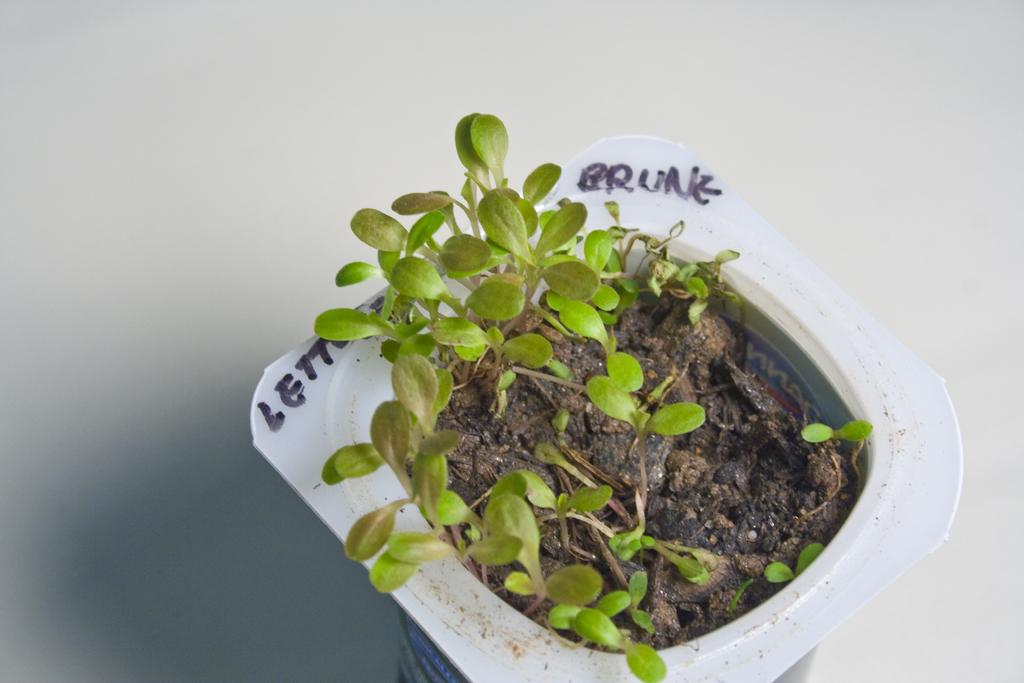What type of living organisms are in the image? There are plants in the image. How are the plants arranged or contained? The plants are in a container. Where is the container with the plants located? The container is placed on a surface. What type of quilt is being used to cover the plants in the image? There is no quilt present in the image; the plants are in a container on a surface. 